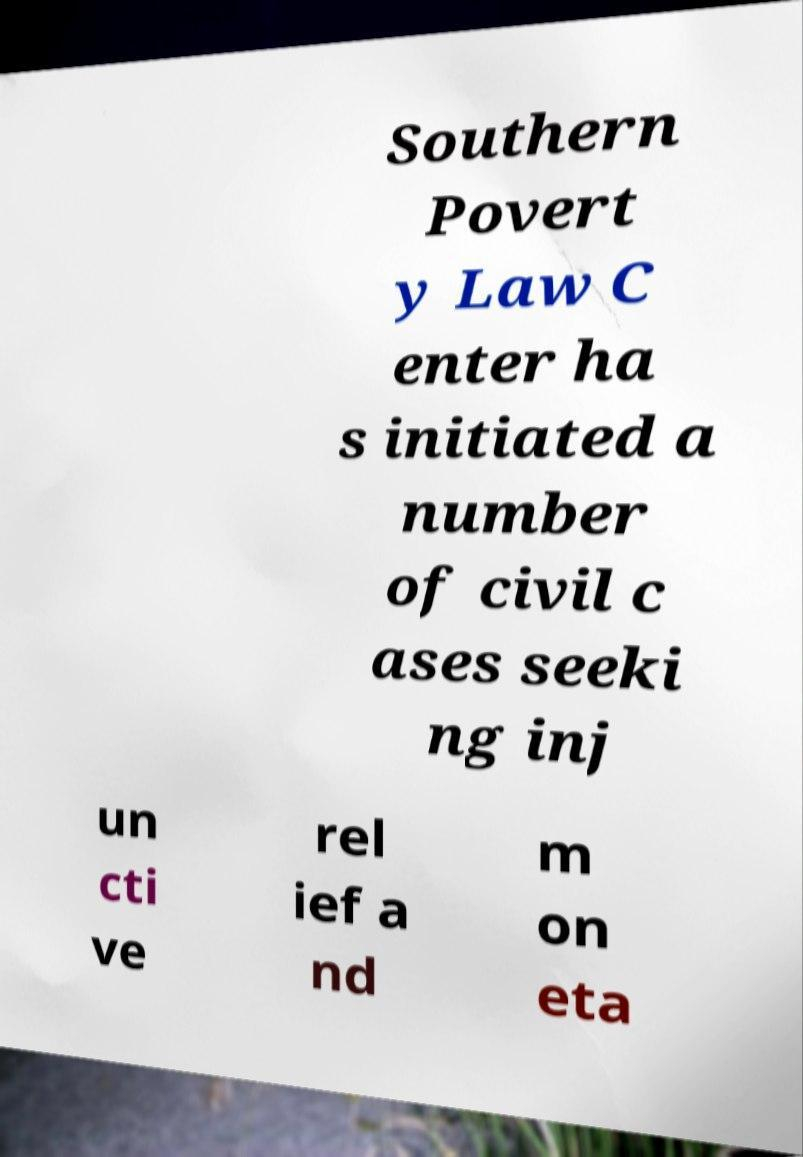Please read and relay the text visible in this image. What does it say? Southern Povert y Law C enter ha s initiated a number of civil c ases seeki ng inj un cti ve rel ief a nd m on eta 